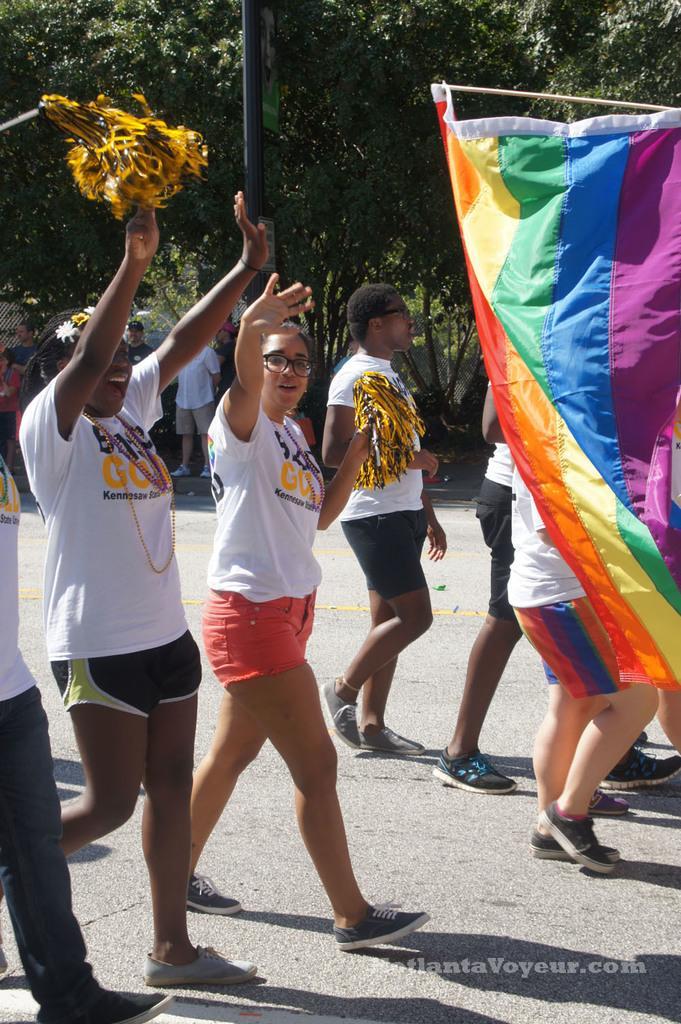Describe this image in one or two sentences. In this image we can see men and women are walking on road and cheering. Right side of the image one flag is there. Background of the image tree are present and one pole is there. 